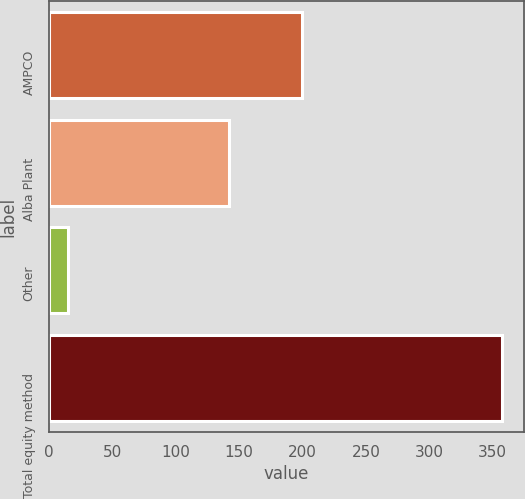<chart> <loc_0><loc_0><loc_500><loc_500><bar_chart><fcel>AMPCO<fcel>Alba Plant<fcel>Other<fcel>Total equity method<nl><fcel>200<fcel>142<fcel>15<fcel>357<nl></chart> 